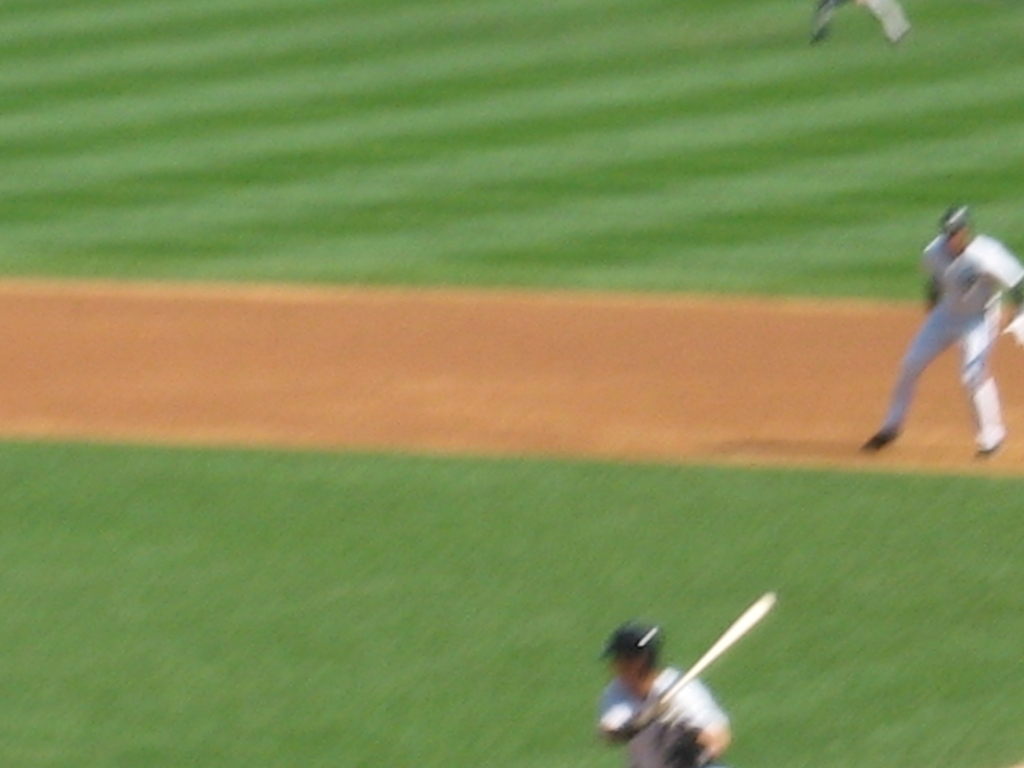Can you explain what's happening in this image? Certainly! This image captures a moment during a baseball game, with one player batting and another one pitching. However, due to motion blur, specific details are difficult to make out, giving the image a dynamic but unclear appearance. What could have been done to make the image clearer? To achieve a clearer image, especially in action shots like this, a faster shutter speed would be necessary to freeze the motion. Additionally, ensuring adequate lighting and possibly using a higher ISO setting could help the camera capture the scene with better clarity and sharpness. 